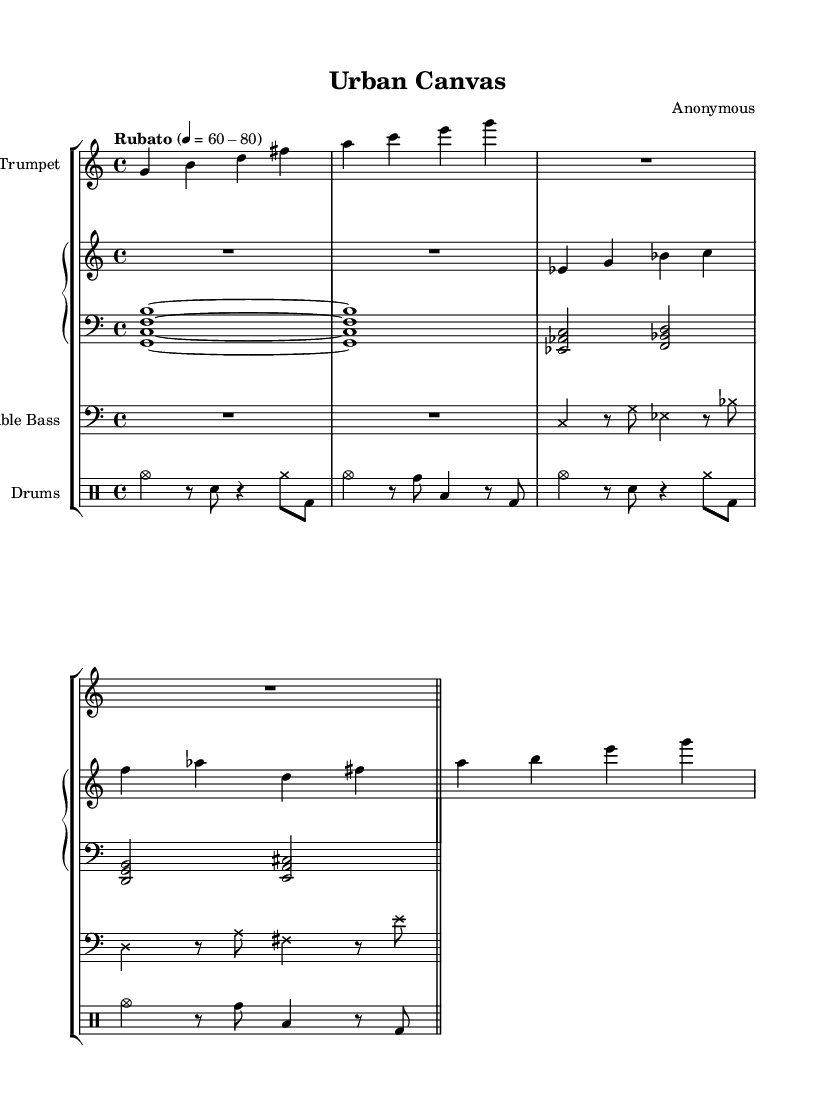What is the time signature of this piece? The time signature is indicated at the beginning of the score with a fraction format. It shows 4 beats per measure, represented as 4/4.
Answer: 4/4 What is the tempo marking for the music? The tempo is marked as "Rubato" with a range specified from 60 to 80 beats per minute. This indicates a flexible tempo.
Answer: Rubato, 60-80 How many measures are in the trumpet part? The trumpet music displays two measures before the end bar line, indicating the total count of measures within that section.
Answer: 2 What style ensemble is represented in this score? The presence of a trumpet, piano, double bass, and drums suggests that this is a jazz ensemble, as these instruments are commonly found in such groups.
Answer: Jazz ensemble What is the role of the double bass in this composition? The double bass part, defined with cross note heads, typically contributes the harmonic foundation and rhythmic support, which is a general function in jazz music.
Answer: Harmonic foundation What visual representation style is employed in this piece? The integration of spoken word and visual elements combined with the typical jazz instrumentation suggests a multi-disciplinary approach, commonly employed in experimental jazz performances.
Answer: Experimental jazz 